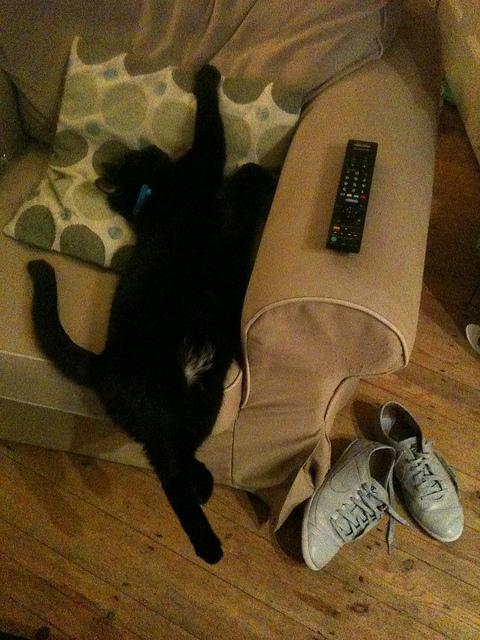What brand are the shoes on the ground?

Choices:
A) vans
B) adidas
C) reebok
D) nike nike 